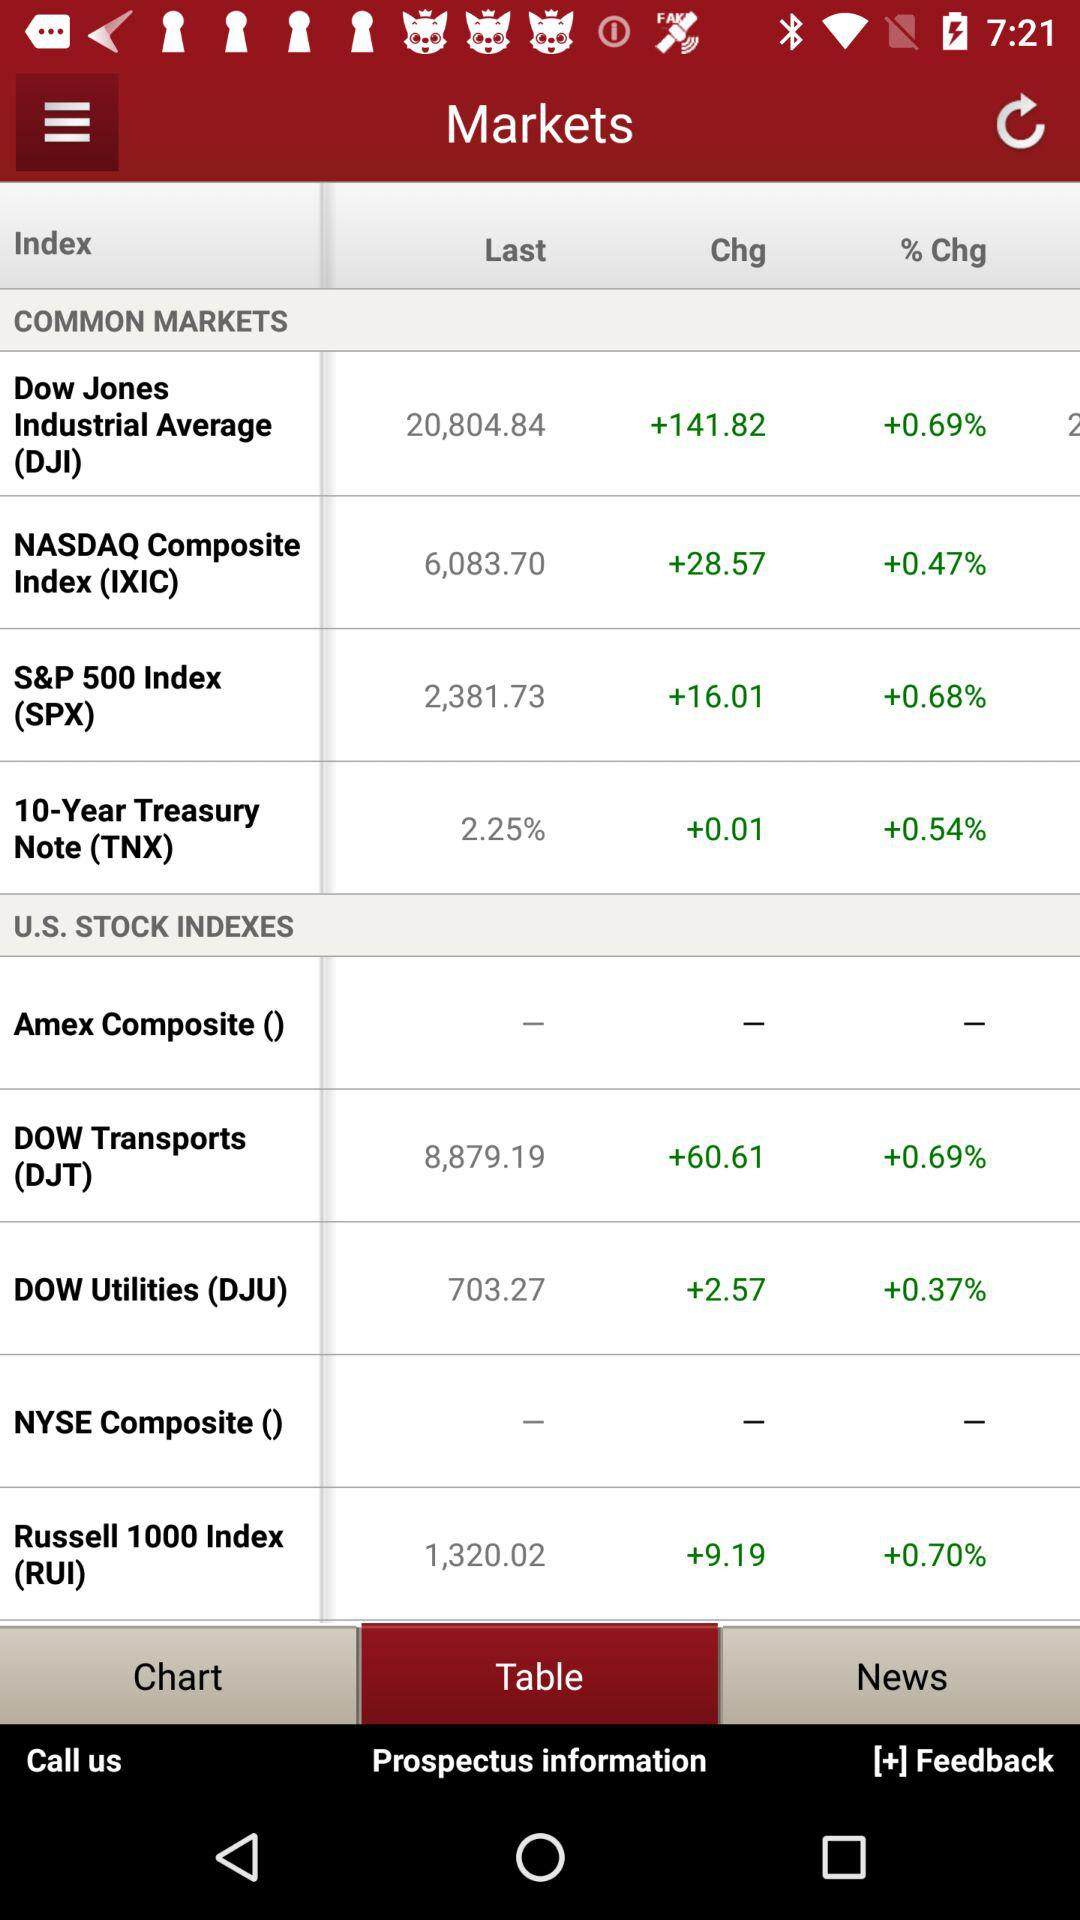How much has Russell 1000 Index changed in percentage terms?
Answer the question using a single word or phrase. 0.70% 